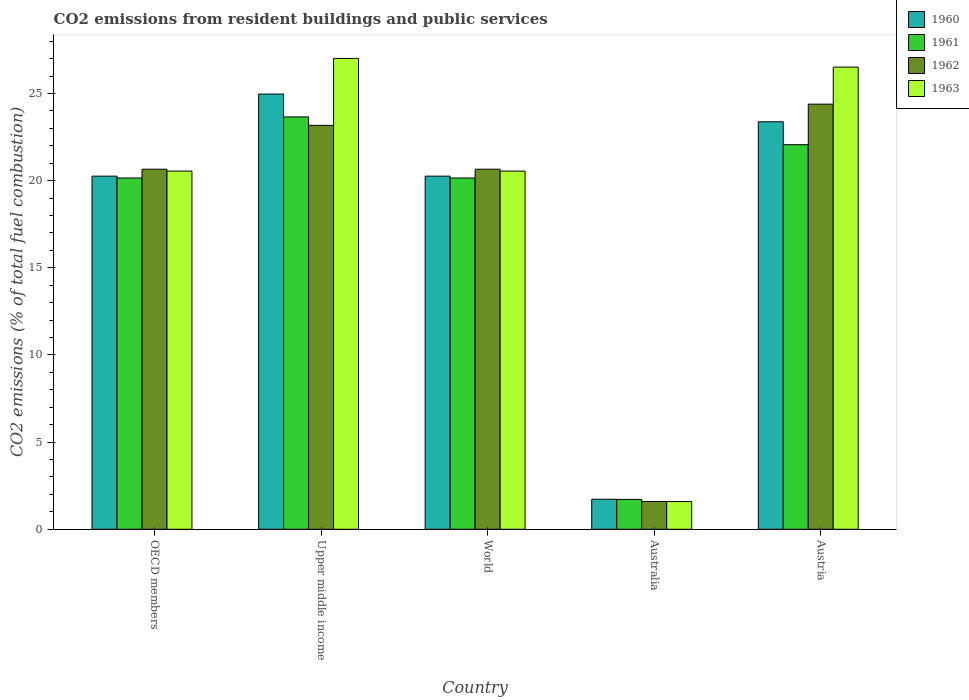How many different coloured bars are there?
Your answer should be very brief. 4. How many groups of bars are there?
Keep it short and to the point. 5. Are the number of bars per tick equal to the number of legend labels?
Provide a succinct answer. Yes. Are the number of bars on each tick of the X-axis equal?
Ensure brevity in your answer.  Yes. How many bars are there on the 3rd tick from the left?
Offer a terse response. 4. In how many cases, is the number of bars for a given country not equal to the number of legend labels?
Provide a succinct answer. 0. What is the total CO2 emitted in 1961 in Austria?
Your response must be concise. 22.06. Across all countries, what is the maximum total CO2 emitted in 1960?
Keep it short and to the point. 24.97. Across all countries, what is the minimum total CO2 emitted in 1963?
Make the answer very short. 1.59. In which country was the total CO2 emitted in 1961 maximum?
Your answer should be compact. Upper middle income. What is the total total CO2 emitted in 1960 in the graph?
Provide a short and direct response. 90.59. What is the difference between the total CO2 emitted in 1963 in Austria and that in World?
Make the answer very short. 5.96. What is the difference between the total CO2 emitted in 1960 in Australia and the total CO2 emitted in 1963 in World?
Offer a very short reply. -18.83. What is the average total CO2 emitted in 1960 per country?
Keep it short and to the point. 18.12. What is the difference between the total CO2 emitted of/in 1963 and total CO2 emitted of/in 1962 in OECD members?
Ensure brevity in your answer.  -0.11. In how many countries, is the total CO2 emitted in 1963 greater than 6?
Your answer should be very brief. 4. What is the ratio of the total CO2 emitted in 1960 in Australia to that in World?
Your answer should be very brief. 0.09. Is the total CO2 emitted in 1962 in Austria less than that in Upper middle income?
Offer a terse response. No. Is the difference between the total CO2 emitted in 1963 in Australia and OECD members greater than the difference between the total CO2 emitted in 1962 in Australia and OECD members?
Your answer should be compact. Yes. What is the difference between the highest and the second highest total CO2 emitted in 1961?
Offer a terse response. -1.91. What is the difference between the highest and the lowest total CO2 emitted in 1962?
Make the answer very short. 22.8. Is it the case that in every country, the sum of the total CO2 emitted in 1963 and total CO2 emitted in 1960 is greater than the total CO2 emitted in 1961?
Ensure brevity in your answer.  Yes. How many bars are there?
Provide a succinct answer. 20. Are all the bars in the graph horizontal?
Provide a short and direct response. No. How many countries are there in the graph?
Give a very brief answer. 5. What is the difference between two consecutive major ticks on the Y-axis?
Keep it short and to the point. 5. Does the graph contain any zero values?
Make the answer very short. No. How many legend labels are there?
Your response must be concise. 4. How are the legend labels stacked?
Give a very brief answer. Vertical. What is the title of the graph?
Your answer should be very brief. CO2 emissions from resident buildings and public services. Does "1966" appear as one of the legend labels in the graph?
Offer a very short reply. No. What is the label or title of the Y-axis?
Offer a very short reply. CO2 emissions (% of total fuel combustion). What is the CO2 emissions (% of total fuel combustion) in 1960 in OECD members?
Your response must be concise. 20.26. What is the CO2 emissions (% of total fuel combustion) of 1961 in OECD members?
Keep it short and to the point. 20.15. What is the CO2 emissions (% of total fuel combustion) in 1962 in OECD members?
Provide a succinct answer. 20.66. What is the CO2 emissions (% of total fuel combustion) in 1963 in OECD members?
Your response must be concise. 20.55. What is the CO2 emissions (% of total fuel combustion) of 1960 in Upper middle income?
Keep it short and to the point. 24.97. What is the CO2 emissions (% of total fuel combustion) of 1961 in Upper middle income?
Offer a terse response. 23.66. What is the CO2 emissions (% of total fuel combustion) in 1962 in Upper middle income?
Ensure brevity in your answer.  23.17. What is the CO2 emissions (% of total fuel combustion) in 1963 in Upper middle income?
Your answer should be compact. 27.01. What is the CO2 emissions (% of total fuel combustion) in 1960 in World?
Offer a very short reply. 20.26. What is the CO2 emissions (% of total fuel combustion) in 1961 in World?
Your answer should be very brief. 20.15. What is the CO2 emissions (% of total fuel combustion) of 1962 in World?
Give a very brief answer. 20.66. What is the CO2 emissions (% of total fuel combustion) in 1963 in World?
Your answer should be very brief. 20.55. What is the CO2 emissions (% of total fuel combustion) in 1960 in Australia?
Provide a short and direct response. 1.72. What is the CO2 emissions (% of total fuel combustion) in 1961 in Australia?
Keep it short and to the point. 1.71. What is the CO2 emissions (% of total fuel combustion) of 1962 in Australia?
Your answer should be compact. 1.59. What is the CO2 emissions (% of total fuel combustion) in 1963 in Australia?
Make the answer very short. 1.59. What is the CO2 emissions (% of total fuel combustion) in 1960 in Austria?
Your answer should be compact. 23.38. What is the CO2 emissions (% of total fuel combustion) of 1961 in Austria?
Provide a succinct answer. 22.06. What is the CO2 emissions (% of total fuel combustion) in 1962 in Austria?
Make the answer very short. 24.39. What is the CO2 emissions (% of total fuel combustion) of 1963 in Austria?
Ensure brevity in your answer.  26.52. Across all countries, what is the maximum CO2 emissions (% of total fuel combustion) of 1960?
Your answer should be compact. 24.97. Across all countries, what is the maximum CO2 emissions (% of total fuel combustion) of 1961?
Offer a very short reply. 23.66. Across all countries, what is the maximum CO2 emissions (% of total fuel combustion) in 1962?
Your response must be concise. 24.39. Across all countries, what is the maximum CO2 emissions (% of total fuel combustion) in 1963?
Give a very brief answer. 27.01. Across all countries, what is the minimum CO2 emissions (% of total fuel combustion) of 1960?
Your answer should be very brief. 1.72. Across all countries, what is the minimum CO2 emissions (% of total fuel combustion) in 1961?
Offer a terse response. 1.71. Across all countries, what is the minimum CO2 emissions (% of total fuel combustion) of 1962?
Give a very brief answer. 1.59. Across all countries, what is the minimum CO2 emissions (% of total fuel combustion) in 1963?
Your answer should be compact. 1.59. What is the total CO2 emissions (% of total fuel combustion) of 1960 in the graph?
Your answer should be very brief. 90.59. What is the total CO2 emissions (% of total fuel combustion) in 1961 in the graph?
Offer a very short reply. 87.75. What is the total CO2 emissions (% of total fuel combustion) of 1962 in the graph?
Provide a short and direct response. 90.48. What is the total CO2 emissions (% of total fuel combustion) of 1963 in the graph?
Offer a terse response. 96.22. What is the difference between the CO2 emissions (% of total fuel combustion) of 1960 in OECD members and that in Upper middle income?
Give a very brief answer. -4.71. What is the difference between the CO2 emissions (% of total fuel combustion) of 1961 in OECD members and that in Upper middle income?
Give a very brief answer. -3.51. What is the difference between the CO2 emissions (% of total fuel combustion) in 1962 in OECD members and that in Upper middle income?
Your response must be concise. -2.52. What is the difference between the CO2 emissions (% of total fuel combustion) of 1963 in OECD members and that in Upper middle income?
Provide a short and direct response. -6.46. What is the difference between the CO2 emissions (% of total fuel combustion) in 1960 in OECD members and that in World?
Your response must be concise. 0. What is the difference between the CO2 emissions (% of total fuel combustion) of 1961 in OECD members and that in World?
Make the answer very short. 0. What is the difference between the CO2 emissions (% of total fuel combustion) of 1962 in OECD members and that in World?
Provide a succinct answer. 0. What is the difference between the CO2 emissions (% of total fuel combustion) in 1960 in OECD members and that in Australia?
Ensure brevity in your answer.  18.54. What is the difference between the CO2 emissions (% of total fuel combustion) of 1961 in OECD members and that in Australia?
Provide a succinct answer. 18.44. What is the difference between the CO2 emissions (% of total fuel combustion) of 1962 in OECD members and that in Australia?
Ensure brevity in your answer.  19.06. What is the difference between the CO2 emissions (% of total fuel combustion) in 1963 in OECD members and that in Australia?
Offer a very short reply. 18.96. What is the difference between the CO2 emissions (% of total fuel combustion) of 1960 in OECD members and that in Austria?
Make the answer very short. -3.12. What is the difference between the CO2 emissions (% of total fuel combustion) in 1961 in OECD members and that in Austria?
Provide a succinct answer. -1.91. What is the difference between the CO2 emissions (% of total fuel combustion) of 1962 in OECD members and that in Austria?
Your answer should be very brief. -3.73. What is the difference between the CO2 emissions (% of total fuel combustion) of 1963 in OECD members and that in Austria?
Offer a terse response. -5.96. What is the difference between the CO2 emissions (% of total fuel combustion) of 1960 in Upper middle income and that in World?
Your answer should be compact. 4.71. What is the difference between the CO2 emissions (% of total fuel combustion) in 1961 in Upper middle income and that in World?
Keep it short and to the point. 3.51. What is the difference between the CO2 emissions (% of total fuel combustion) in 1962 in Upper middle income and that in World?
Your answer should be very brief. 2.52. What is the difference between the CO2 emissions (% of total fuel combustion) in 1963 in Upper middle income and that in World?
Provide a short and direct response. 6.46. What is the difference between the CO2 emissions (% of total fuel combustion) in 1960 in Upper middle income and that in Australia?
Provide a short and direct response. 23.25. What is the difference between the CO2 emissions (% of total fuel combustion) in 1961 in Upper middle income and that in Australia?
Your answer should be compact. 21.95. What is the difference between the CO2 emissions (% of total fuel combustion) in 1962 in Upper middle income and that in Australia?
Make the answer very short. 21.58. What is the difference between the CO2 emissions (% of total fuel combustion) in 1963 in Upper middle income and that in Australia?
Ensure brevity in your answer.  25.42. What is the difference between the CO2 emissions (% of total fuel combustion) of 1960 in Upper middle income and that in Austria?
Your response must be concise. 1.59. What is the difference between the CO2 emissions (% of total fuel combustion) of 1961 in Upper middle income and that in Austria?
Keep it short and to the point. 1.6. What is the difference between the CO2 emissions (% of total fuel combustion) of 1962 in Upper middle income and that in Austria?
Make the answer very short. -1.22. What is the difference between the CO2 emissions (% of total fuel combustion) of 1963 in Upper middle income and that in Austria?
Make the answer very short. 0.5. What is the difference between the CO2 emissions (% of total fuel combustion) in 1960 in World and that in Australia?
Your answer should be very brief. 18.54. What is the difference between the CO2 emissions (% of total fuel combustion) in 1961 in World and that in Australia?
Provide a succinct answer. 18.44. What is the difference between the CO2 emissions (% of total fuel combustion) in 1962 in World and that in Australia?
Provide a succinct answer. 19.06. What is the difference between the CO2 emissions (% of total fuel combustion) of 1963 in World and that in Australia?
Offer a very short reply. 18.96. What is the difference between the CO2 emissions (% of total fuel combustion) of 1960 in World and that in Austria?
Provide a succinct answer. -3.12. What is the difference between the CO2 emissions (% of total fuel combustion) in 1961 in World and that in Austria?
Your answer should be compact. -1.91. What is the difference between the CO2 emissions (% of total fuel combustion) of 1962 in World and that in Austria?
Your answer should be very brief. -3.73. What is the difference between the CO2 emissions (% of total fuel combustion) of 1963 in World and that in Austria?
Offer a very short reply. -5.96. What is the difference between the CO2 emissions (% of total fuel combustion) of 1960 in Australia and that in Austria?
Your answer should be compact. -21.65. What is the difference between the CO2 emissions (% of total fuel combustion) in 1961 in Australia and that in Austria?
Keep it short and to the point. -20.35. What is the difference between the CO2 emissions (% of total fuel combustion) in 1962 in Australia and that in Austria?
Ensure brevity in your answer.  -22.8. What is the difference between the CO2 emissions (% of total fuel combustion) of 1963 in Australia and that in Austria?
Your answer should be very brief. -24.92. What is the difference between the CO2 emissions (% of total fuel combustion) in 1960 in OECD members and the CO2 emissions (% of total fuel combustion) in 1961 in Upper middle income?
Provide a succinct answer. -3.4. What is the difference between the CO2 emissions (% of total fuel combustion) of 1960 in OECD members and the CO2 emissions (% of total fuel combustion) of 1962 in Upper middle income?
Your answer should be very brief. -2.91. What is the difference between the CO2 emissions (% of total fuel combustion) in 1960 in OECD members and the CO2 emissions (% of total fuel combustion) in 1963 in Upper middle income?
Give a very brief answer. -6.75. What is the difference between the CO2 emissions (% of total fuel combustion) of 1961 in OECD members and the CO2 emissions (% of total fuel combustion) of 1962 in Upper middle income?
Provide a short and direct response. -3.02. What is the difference between the CO2 emissions (% of total fuel combustion) in 1961 in OECD members and the CO2 emissions (% of total fuel combustion) in 1963 in Upper middle income?
Your answer should be compact. -6.86. What is the difference between the CO2 emissions (% of total fuel combustion) of 1962 in OECD members and the CO2 emissions (% of total fuel combustion) of 1963 in Upper middle income?
Make the answer very short. -6.36. What is the difference between the CO2 emissions (% of total fuel combustion) of 1960 in OECD members and the CO2 emissions (% of total fuel combustion) of 1961 in World?
Your response must be concise. 0.11. What is the difference between the CO2 emissions (% of total fuel combustion) of 1960 in OECD members and the CO2 emissions (% of total fuel combustion) of 1962 in World?
Your answer should be very brief. -0.4. What is the difference between the CO2 emissions (% of total fuel combustion) in 1960 in OECD members and the CO2 emissions (% of total fuel combustion) in 1963 in World?
Offer a terse response. -0.29. What is the difference between the CO2 emissions (% of total fuel combustion) in 1961 in OECD members and the CO2 emissions (% of total fuel combustion) in 1962 in World?
Ensure brevity in your answer.  -0.5. What is the difference between the CO2 emissions (% of total fuel combustion) of 1961 in OECD members and the CO2 emissions (% of total fuel combustion) of 1963 in World?
Give a very brief answer. -0.4. What is the difference between the CO2 emissions (% of total fuel combustion) of 1962 in OECD members and the CO2 emissions (% of total fuel combustion) of 1963 in World?
Your response must be concise. 0.11. What is the difference between the CO2 emissions (% of total fuel combustion) in 1960 in OECD members and the CO2 emissions (% of total fuel combustion) in 1961 in Australia?
Make the answer very short. 18.55. What is the difference between the CO2 emissions (% of total fuel combustion) of 1960 in OECD members and the CO2 emissions (% of total fuel combustion) of 1962 in Australia?
Offer a very short reply. 18.67. What is the difference between the CO2 emissions (% of total fuel combustion) in 1960 in OECD members and the CO2 emissions (% of total fuel combustion) in 1963 in Australia?
Provide a short and direct response. 18.67. What is the difference between the CO2 emissions (% of total fuel combustion) in 1961 in OECD members and the CO2 emissions (% of total fuel combustion) in 1962 in Australia?
Offer a very short reply. 18.56. What is the difference between the CO2 emissions (% of total fuel combustion) in 1961 in OECD members and the CO2 emissions (% of total fuel combustion) in 1963 in Australia?
Your answer should be very brief. 18.56. What is the difference between the CO2 emissions (% of total fuel combustion) of 1962 in OECD members and the CO2 emissions (% of total fuel combustion) of 1963 in Australia?
Your answer should be compact. 19.07. What is the difference between the CO2 emissions (% of total fuel combustion) in 1960 in OECD members and the CO2 emissions (% of total fuel combustion) in 1961 in Austria?
Provide a succinct answer. -1.8. What is the difference between the CO2 emissions (% of total fuel combustion) in 1960 in OECD members and the CO2 emissions (% of total fuel combustion) in 1962 in Austria?
Offer a terse response. -4.13. What is the difference between the CO2 emissions (% of total fuel combustion) in 1960 in OECD members and the CO2 emissions (% of total fuel combustion) in 1963 in Austria?
Your answer should be compact. -6.26. What is the difference between the CO2 emissions (% of total fuel combustion) in 1961 in OECD members and the CO2 emissions (% of total fuel combustion) in 1962 in Austria?
Keep it short and to the point. -4.24. What is the difference between the CO2 emissions (% of total fuel combustion) of 1961 in OECD members and the CO2 emissions (% of total fuel combustion) of 1963 in Austria?
Provide a succinct answer. -6.36. What is the difference between the CO2 emissions (% of total fuel combustion) in 1962 in OECD members and the CO2 emissions (% of total fuel combustion) in 1963 in Austria?
Your response must be concise. -5.86. What is the difference between the CO2 emissions (% of total fuel combustion) of 1960 in Upper middle income and the CO2 emissions (% of total fuel combustion) of 1961 in World?
Offer a terse response. 4.82. What is the difference between the CO2 emissions (% of total fuel combustion) of 1960 in Upper middle income and the CO2 emissions (% of total fuel combustion) of 1962 in World?
Offer a very short reply. 4.31. What is the difference between the CO2 emissions (% of total fuel combustion) in 1960 in Upper middle income and the CO2 emissions (% of total fuel combustion) in 1963 in World?
Your response must be concise. 4.42. What is the difference between the CO2 emissions (% of total fuel combustion) of 1961 in Upper middle income and the CO2 emissions (% of total fuel combustion) of 1962 in World?
Make the answer very short. 3. What is the difference between the CO2 emissions (% of total fuel combustion) of 1961 in Upper middle income and the CO2 emissions (% of total fuel combustion) of 1963 in World?
Offer a very short reply. 3.11. What is the difference between the CO2 emissions (% of total fuel combustion) of 1962 in Upper middle income and the CO2 emissions (% of total fuel combustion) of 1963 in World?
Your answer should be compact. 2.62. What is the difference between the CO2 emissions (% of total fuel combustion) of 1960 in Upper middle income and the CO2 emissions (% of total fuel combustion) of 1961 in Australia?
Ensure brevity in your answer.  23.26. What is the difference between the CO2 emissions (% of total fuel combustion) in 1960 in Upper middle income and the CO2 emissions (% of total fuel combustion) in 1962 in Australia?
Your response must be concise. 23.38. What is the difference between the CO2 emissions (% of total fuel combustion) of 1960 in Upper middle income and the CO2 emissions (% of total fuel combustion) of 1963 in Australia?
Your answer should be compact. 23.38. What is the difference between the CO2 emissions (% of total fuel combustion) in 1961 in Upper middle income and the CO2 emissions (% of total fuel combustion) in 1962 in Australia?
Provide a short and direct response. 22.07. What is the difference between the CO2 emissions (% of total fuel combustion) of 1961 in Upper middle income and the CO2 emissions (% of total fuel combustion) of 1963 in Australia?
Provide a succinct answer. 22.07. What is the difference between the CO2 emissions (% of total fuel combustion) of 1962 in Upper middle income and the CO2 emissions (% of total fuel combustion) of 1963 in Australia?
Keep it short and to the point. 21.58. What is the difference between the CO2 emissions (% of total fuel combustion) in 1960 in Upper middle income and the CO2 emissions (% of total fuel combustion) in 1961 in Austria?
Provide a short and direct response. 2.9. What is the difference between the CO2 emissions (% of total fuel combustion) of 1960 in Upper middle income and the CO2 emissions (% of total fuel combustion) of 1962 in Austria?
Your response must be concise. 0.58. What is the difference between the CO2 emissions (% of total fuel combustion) of 1960 in Upper middle income and the CO2 emissions (% of total fuel combustion) of 1963 in Austria?
Provide a succinct answer. -1.55. What is the difference between the CO2 emissions (% of total fuel combustion) in 1961 in Upper middle income and the CO2 emissions (% of total fuel combustion) in 1962 in Austria?
Give a very brief answer. -0.73. What is the difference between the CO2 emissions (% of total fuel combustion) of 1961 in Upper middle income and the CO2 emissions (% of total fuel combustion) of 1963 in Austria?
Your response must be concise. -2.86. What is the difference between the CO2 emissions (% of total fuel combustion) in 1962 in Upper middle income and the CO2 emissions (% of total fuel combustion) in 1963 in Austria?
Provide a succinct answer. -3.34. What is the difference between the CO2 emissions (% of total fuel combustion) of 1960 in World and the CO2 emissions (% of total fuel combustion) of 1961 in Australia?
Give a very brief answer. 18.55. What is the difference between the CO2 emissions (% of total fuel combustion) of 1960 in World and the CO2 emissions (% of total fuel combustion) of 1962 in Australia?
Ensure brevity in your answer.  18.67. What is the difference between the CO2 emissions (% of total fuel combustion) of 1960 in World and the CO2 emissions (% of total fuel combustion) of 1963 in Australia?
Give a very brief answer. 18.67. What is the difference between the CO2 emissions (% of total fuel combustion) in 1961 in World and the CO2 emissions (% of total fuel combustion) in 1962 in Australia?
Offer a terse response. 18.56. What is the difference between the CO2 emissions (% of total fuel combustion) of 1961 in World and the CO2 emissions (% of total fuel combustion) of 1963 in Australia?
Offer a very short reply. 18.56. What is the difference between the CO2 emissions (% of total fuel combustion) in 1962 in World and the CO2 emissions (% of total fuel combustion) in 1963 in Australia?
Offer a terse response. 19.07. What is the difference between the CO2 emissions (% of total fuel combustion) in 1960 in World and the CO2 emissions (% of total fuel combustion) in 1961 in Austria?
Your response must be concise. -1.8. What is the difference between the CO2 emissions (% of total fuel combustion) of 1960 in World and the CO2 emissions (% of total fuel combustion) of 1962 in Austria?
Your answer should be very brief. -4.13. What is the difference between the CO2 emissions (% of total fuel combustion) in 1960 in World and the CO2 emissions (% of total fuel combustion) in 1963 in Austria?
Provide a short and direct response. -6.26. What is the difference between the CO2 emissions (% of total fuel combustion) in 1961 in World and the CO2 emissions (% of total fuel combustion) in 1962 in Austria?
Make the answer very short. -4.24. What is the difference between the CO2 emissions (% of total fuel combustion) of 1961 in World and the CO2 emissions (% of total fuel combustion) of 1963 in Austria?
Your answer should be very brief. -6.36. What is the difference between the CO2 emissions (% of total fuel combustion) in 1962 in World and the CO2 emissions (% of total fuel combustion) in 1963 in Austria?
Give a very brief answer. -5.86. What is the difference between the CO2 emissions (% of total fuel combustion) in 1960 in Australia and the CO2 emissions (% of total fuel combustion) in 1961 in Austria?
Your response must be concise. -20.34. What is the difference between the CO2 emissions (% of total fuel combustion) of 1960 in Australia and the CO2 emissions (% of total fuel combustion) of 1962 in Austria?
Ensure brevity in your answer.  -22.67. What is the difference between the CO2 emissions (% of total fuel combustion) in 1960 in Australia and the CO2 emissions (% of total fuel combustion) in 1963 in Austria?
Give a very brief answer. -24.79. What is the difference between the CO2 emissions (% of total fuel combustion) of 1961 in Australia and the CO2 emissions (% of total fuel combustion) of 1962 in Austria?
Give a very brief answer. -22.68. What is the difference between the CO2 emissions (% of total fuel combustion) of 1961 in Australia and the CO2 emissions (% of total fuel combustion) of 1963 in Austria?
Your response must be concise. -24.8. What is the difference between the CO2 emissions (% of total fuel combustion) of 1962 in Australia and the CO2 emissions (% of total fuel combustion) of 1963 in Austria?
Make the answer very short. -24.92. What is the average CO2 emissions (% of total fuel combustion) in 1960 per country?
Offer a terse response. 18.12. What is the average CO2 emissions (% of total fuel combustion) of 1961 per country?
Give a very brief answer. 17.55. What is the average CO2 emissions (% of total fuel combustion) of 1962 per country?
Your answer should be very brief. 18.1. What is the average CO2 emissions (% of total fuel combustion) in 1963 per country?
Give a very brief answer. 19.24. What is the difference between the CO2 emissions (% of total fuel combustion) of 1960 and CO2 emissions (% of total fuel combustion) of 1961 in OECD members?
Offer a terse response. 0.11. What is the difference between the CO2 emissions (% of total fuel combustion) of 1960 and CO2 emissions (% of total fuel combustion) of 1962 in OECD members?
Keep it short and to the point. -0.4. What is the difference between the CO2 emissions (% of total fuel combustion) of 1960 and CO2 emissions (% of total fuel combustion) of 1963 in OECD members?
Your answer should be very brief. -0.29. What is the difference between the CO2 emissions (% of total fuel combustion) of 1961 and CO2 emissions (% of total fuel combustion) of 1962 in OECD members?
Offer a very short reply. -0.5. What is the difference between the CO2 emissions (% of total fuel combustion) of 1961 and CO2 emissions (% of total fuel combustion) of 1963 in OECD members?
Your answer should be compact. -0.4. What is the difference between the CO2 emissions (% of total fuel combustion) of 1962 and CO2 emissions (% of total fuel combustion) of 1963 in OECD members?
Offer a very short reply. 0.11. What is the difference between the CO2 emissions (% of total fuel combustion) in 1960 and CO2 emissions (% of total fuel combustion) in 1961 in Upper middle income?
Provide a short and direct response. 1.31. What is the difference between the CO2 emissions (% of total fuel combustion) of 1960 and CO2 emissions (% of total fuel combustion) of 1962 in Upper middle income?
Provide a succinct answer. 1.8. What is the difference between the CO2 emissions (% of total fuel combustion) in 1960 and CO2 emissions (% of total fuel combustion) in 1963 in Upper middle income?
Your answer should be compact. -2.05. What is the difference between the CO2 emissions (% of total fuel combustion) in 1961 and CO2 emissions (% of total fuel combustion) in 1962 in Upper middle income?
Offer a terse response. 0.49. What is the difference between the CO2 emissions (% of total fuel combustion) in 1961 and CO2 emissions (% of total fuel combustion) in 1963 in Upper middle income?
Give a very brief answer. -3.35. What is the difference between the CO2 emissions (% of total fuel combustion) of 1962 and CO2 emissions (% of total fuel combustion) of 1963 in Upper middle income?
Offer a terse response. -3.84. What is the difference between the CO2 emissions (% of total fuel combustion) in 1960 and CO2 emissions (% of total fuel combustion) in 1961 in World?
Provide a short and direct response. 0.11. What is the difference between the CO2 emissions (% of total fuel combustion) of 1960 and CO2 emissions (% of total fuel combustion) of 1962 in World?
Your answer should be compact. -0.4. What is the difference between the CO2 emissions (% of total fuel combustion) in 1960 and CO2 emissions (% of total fuel combustion) in 1963 in World?
Offer a terse response. -0.29. What is the difference between the CO2 emissions (% of total fuel combustion) in 1961 and CO2 emissions (% of total fuel combustion) in 1962 in World?
Your answer should be very brief. -0.5. What is the difference between the CO2 emissions (% of total fuel combustion) in 1961 and CO2 emissions (% of total fuel combustion) in 1963 in World?
Give a very brief answer. -0.4. What is the difference between the CO2 emissions (% of total fuel combustion) in 1962 and CO2 emissions (% of total fuel combustion) in 1963 in World?
Make the answer very short. 0.11. What is the difference between the CO2 emissions (% of total fuel combustion) in 1960 and CO2 emissions (% of total fuel combustion) in 1961 in Australia?
Provide a succinct answer. 0.01. What is the difference between the CO2 emissions (% of total fuel combustion) in 1960 and CO2 emissions (% of total fuel combustion) in 1962 in Australia?
Ensure brevity in your answer.  0.13. What is the difference between the CO2 emissions (% of total fuel combustion) of 1960 and CO2 emissions (% of total fuel combustion) of 1963 in Australia?
Offer a terse response. 0.13. What is the difference between the CO2 emissions (% of total fuel combustion) of 1961 and CO2 emissions (% of total fuel combustion) of 1962 in Australia?
Keep it short and to the point. 0.12. What is the difference between the CO2 emissions (% of total fuel combustion) in 1961 and CO2 emissions (% of total fuel combustion) in 1963 in Australia?
Your answer should be compact. 0.12. What is the difference between the CO2 emissions (% of total fuel combustion) in 1962 and CO2 emissions (% of total fuel combustion) in 1963 in Australia?
Your answer should be compact. 0. What is the difference between the CO2 emissions (% of total fuel combustion) of 1960 and CO2 emissions (% of total fuel combustion) of 1961 in Austria?
Ensure brevity in your answer.  1.31. What is the difference between the CO2 emissions (% of total fuel combustion) in 1960 and CO2 emissions (% of total fuel combustion) in 1962 in Austria?
Provide a succinct answer. -1.01. What is the difference between the CO2 emissions (% of total fuel combustion) in 1960 and CO2 emissions (% of total fuel combustion) in 1963 in Austria?
Offer a terse response. -3.14. What is the difference between the CO2 emissions (% of total fuel combustion) in 1961 and CO2 emissions (% of total fuel combustion) in 1962 in Austria?
Your answer should be compact. -2.33. What is the difference between the CO2 emissions (% of total fuel combustion) of 1961 and CO2 emissions (% of total fuel combustion) of 1963 in Austria?
Provide a succinct answer. -4.45. What is the difference between the CO2 emissions (% of total fuel combustion) in 1962 and CO2 emissions (% of total fuel combustion) in 1963 in Austria?
Provide a short and direct response. -2.12. What is the ratio of the CO2 emissions (% of total fuel combustion) of 1960 in OECD members to that in Upper middle income?
Your answer should be compact. 0.81. What is the ratio of the CO2 emissions (% of total fuel combustion) of 1961 in OECD members to that in Upper middle income?
Keep it short and to the point. 0.85. What is the ratio of the CO2 emissions (% of total fuel combustion) in 1962 in OECD members to that in Upper middle income?
Keep it short and to the point. 0.89. What is the ratio of the CO2 emissions (% of total fuel combustion) of 1963 in OECD members to that in Upper middle income?
Keep it short and to the point. 0.76. What is the ratio of the CO2 emissions (% of total fuel combustion) of 1960 in OECD members to that in World?
Keep it short and to the point. 1. What is the ratio of the CO2 emissions (% of total fuel combustion) in 1962 in OECD members to that in World?
Give a very brief answer. 1. What is the ratio of the CO2 emissions (% of total fuel combustion) in 1963 in OECD members to that in World?
Provide a succinct answer. 1. What is the ratio of the CO2 emissions (% of total fuel combustion) of 1960 in OECD members to that in Australia?
Your answer should be compact. 11.75. What is the ratio of the CO2 emissions (% of total fuel combustion) in 1961 in OECD members to that in Australia?
Your answer should be very brief. 11.75. What is the ratio of the CO2 emissions (% of total fuel combustion) of 1962 in OECD members to that in Australia?
Provide a succinct answer. 12.96. What is the ratio of the CO2 emissions (% of total fuel combustion) of 1963 in OECD members to that in Australia?
Provide a short and direct response. 12.92. What is the ratio of the CO2 emissions (% of total fuel combustion) of 1960 in OECD members to that in Austria?
Offer a very short reply. 0.87. What is the ratio of the CO2 emissions (% of total fuel combustion) in 1961 in OECD members to that in Austria?
Provide a short and direct response. 0.91. What is the ratio of the CO2 emissions (% of total fuel combustion) of 1962 in OECD members to that in Austria?
Offer a very short reply. 0.85. What is the ratio of the CO2 emissions (% of total fuel combustion) in 1963 in OECD members to that in Austria?
Ensure brevity in your answer.  0.78. What is the ratio of the CO2 emissions (% of total fuel combustion) of 1960 in Upper middle income to that in World?
Keep it short and to the point. 1.23. What is the ratio of the CO2 emissions (% of total fuel combustion) of 1961 in Upper middle income to that in World?
Ensure brevity in your answer.  1.17. What is the ratio of the CO2 emissions (% of total fuel combustion) in 1962 in Upper middle income to that in World?
Your answer should be very brief. 1.12. What is the ratio of the CO2 emissions (% of total fuel combustion) of 1963 in Upper middle income to that in World?
Your answer should be compact. 1.31. What is the ratio of the CO2 emissions (% of total fuel combustion) in 1960 in Upper middle income to that in Australia?
Give a very brief answer. 14.48. What is the ratio of the CO2 emissions (% of total fuel combustion) of 1961 in Upper middle income to that in Australia?
Your answer should be very brief. 13.8. What is the ratio of the CO2 emissions (% of total fuel combustion) in 1962 in Upper middle income to that in Australia?
Provide a short and direct response. 14.53. What is the ratio of the CO2 emissions (% of total fuel combustion) of 1963 in Upper middle income to that in Australia?
Make the answer very short. 16.98. What is the ratio of the CO2 emissions (% of total fuel combustion) in 1960 in Upper middle income to that in Austria?
Ensure brevity in your answer.  1.07. What is the ratio of the CO2 emissions (% of total fuel combustion) in 1961 in Upper middle income to that in Austria?
Your answer should be compact. 1.07. What is the ratio of the CO2 emissions (% of total fuel combustion) of 1962 in Upper middle income to that in Austria?
Ensure brevity in your answer.  0.95. What is the ratio of the CO2 emissions (% of total fuel combustion) in 1963 in Upper middle income to that in Austria?
Keep it short and to the point. 1.02. What is the ratio of the CO2 emissions (% of total fuel combustion) of 1960 in World to that in Australia?
Provide a short and direct response. 11.75. What is the ratio of the CO2 emissions (% of total fuel combustion) in 1961 in World to that in Australia?
Ensure brevity in your answer.  11.75. What is the ratio of the CO2 emissions (% of total fuel combustion) in 1962 in World to that in Australia?
Ensure brevity in your answer.  12.96. What is the ratio of the CO2 emissions (% of total fuel combustion) of 1963 in World to that in Australia?
Ensure brevity in your answer.  12.92. What is the ratio of the CO2 emissions (% of total fuel combustion) in 1960 in World to that in Austria?
Provide a succinct answer. 0.87. What is the ratio of the CO2 emissions (% of total fuel combustion) in 1961 in World to that in Austria?
Provide a short and direct response. 0.91. What is the ratio of the CO2 emissions (% of total fuel combustion) in 1962 in World to that in Austria?
Make the answer very short. 0.85. What is the ratio of the CO2 emissions (% of total fuel combustion) in 1963 in World to that in Austria?
Provide a succinct answer. 0.78. What is the ratio of the CO2 emissions (% of total fuel combustion) of 1960 in Australia to that in Austria?
Your response must be concise. 0.07. What is the ratio of the CO2 emissions (% of total fuel combustion) in 1961 in Australia to that in Austria?
Your answer should be very brief. 0.08. What is the ratio of the CO2 emissions (% of total fuel combustion) of 1962 in Australia to that in Austria?
Provide a short and direct response. 0.07. What is the difference between the highest and the second highest CO2 emissions (% of total fuel combustion) in 1960?
Give a very brief answer. 1.59. What is the difference between the highest and the second highest CO2 emissions (% of total fuel combustion) of 1961?
Your answer should be compact. 1.6. What is the difference between the highest and the second highest CO2 emissions (% of total fuel combustion) of 1962?
Your answer should be compact. 1.22. What is the difference between the highest and the second highest CO2 emissions (% of total fuel combustion) in 1963?
Your answer should be compact. 0.5. What is the difference between the highest and the lowest CO2 emissions (% of total fuel combustion) in 1960?
Keep it short and to the point. 23.25. What is the difference between the highest and the lowest CO2 emissions (% of total fuel combustion) in 1961?
Make the answer very short. 21.95. What is the difference between the highest and the lowest CO2 emissions (% of total fuel combustion) of 1962?
Your answer should be compact. 22.8. What is the difference between the highest and the lowest CO2 emissions (% of total fuel combustion) of 1963?
Your response must be concise. 25.42. 